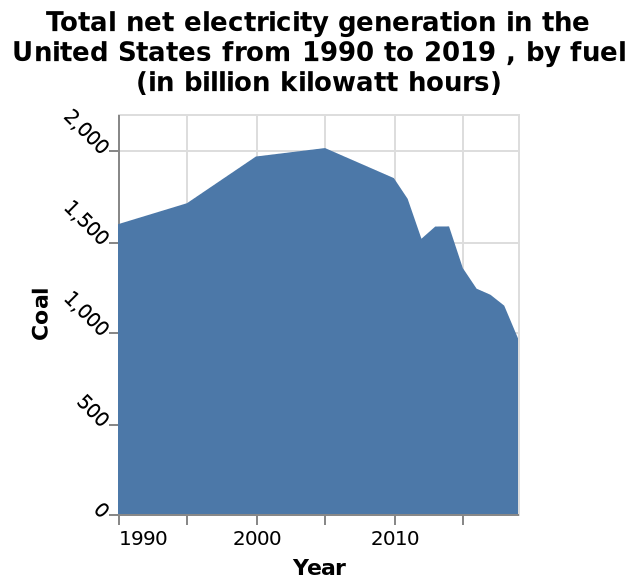<image>
How much has the coal usage decreased between 2005 and 2020?  The coal usage has halved between 2005 and 2020. What is the overall trend in coal usage over the past years? The overall trend in coal usage is a decline since 2005. 